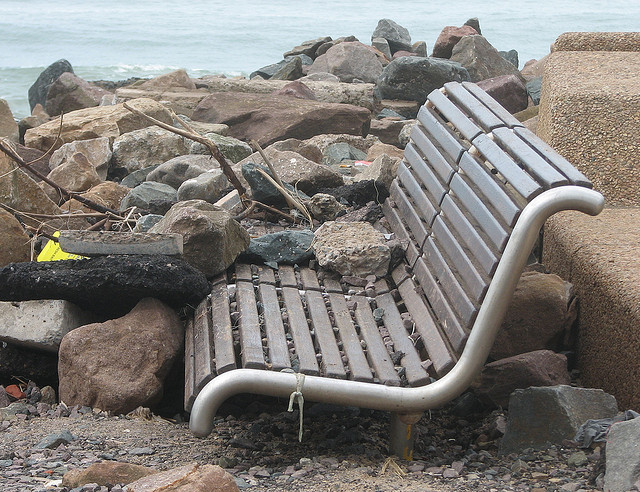How many benches are in the picture? There is one bench visible in the picture, which appears weathered and is situated among rocks near a body of water. 